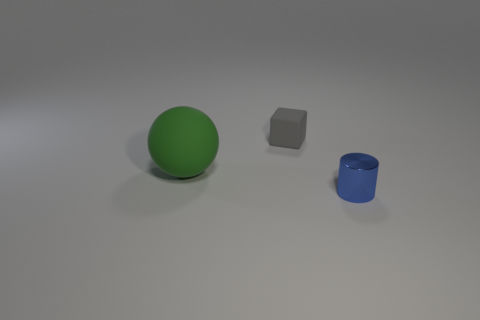Is there anything else that has the same material as the tiny cylinder?
Offer a terse response. No. What number of objects are small objects on the left side of the cylinder or objects that are in front of the gray rubber cube?
Offer a very short reply. 3. Is there any other thing that is the same shape as the gray matte object?
Keep it short and to the point. No. What is the tiny cylinder made of?
Keep it short and to the point. Metal. What number of other things are there of the same material as the blue cylinder
Ensure brevity in your answer.  0. Does the blue cylinder have the same material as the thing on the left side of the gray object?
Give a very brief answer. No. Are there fewer big green matte spheres that are to the left of the big object than objects left of the cylinder?
Your answer should be compact. Yes. The matte object left of the gray matte cube is what color?
Your response must be concise. Green. There is a rubber object that is on the left side of the gray rubber thing; does it have the same size as the cube?
Your response must be concise. No. There is a tiny blue metal cylinder; how many small blocks are behind it?
Offer a very short reply. 1. 